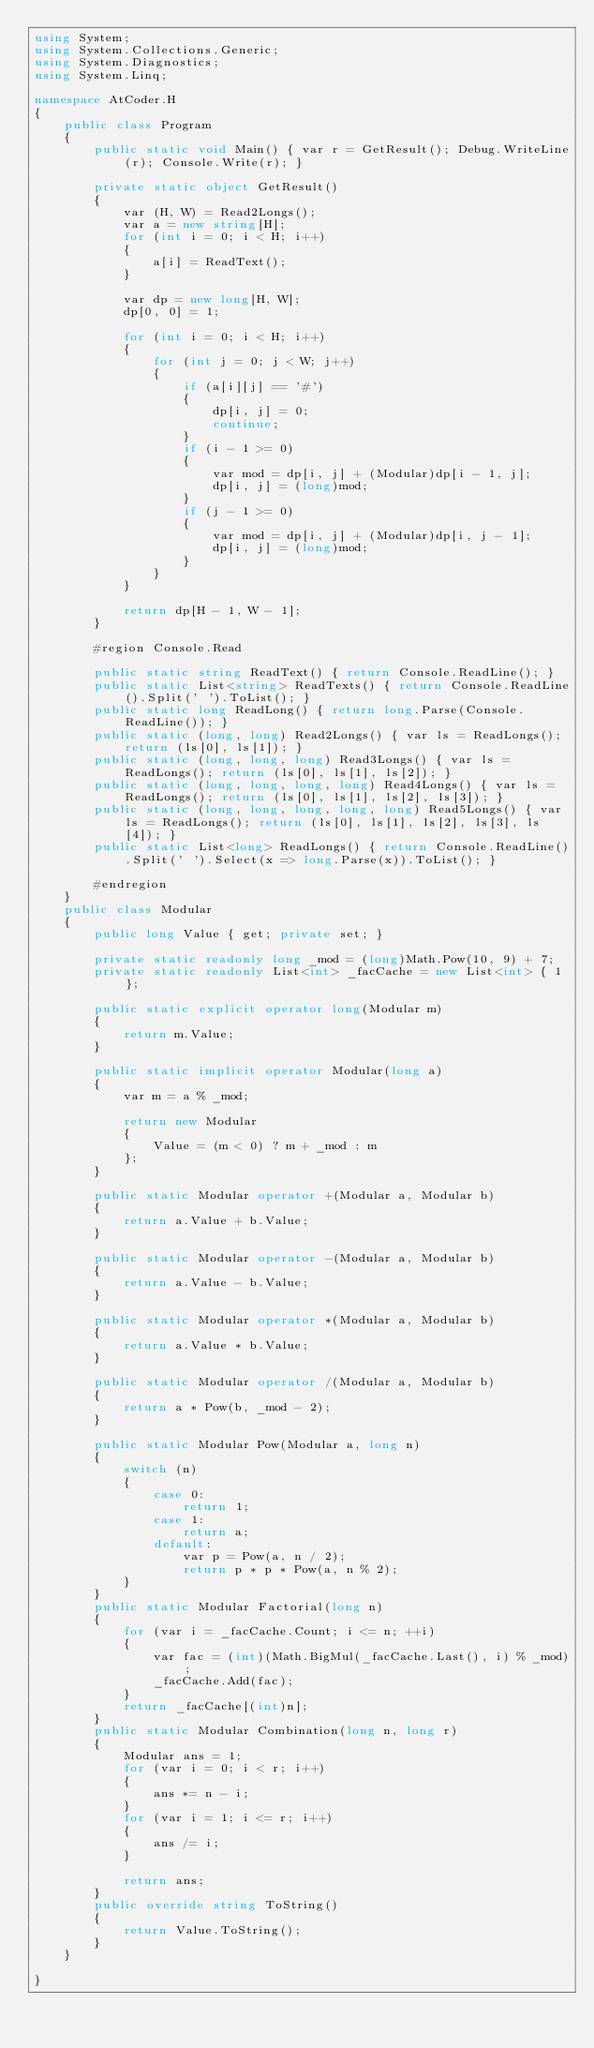<code> <loc_0><loc_0><loc_500><loc_500><_C#_>using System;
using System.Collections.Generic;
using System.Diagnostics;
using System.Linq;

namespace AtCoder.H
{
    public class Program
    {
        public static void Main() { var r = GetResult(); Debug.WriteLine(r); Console.Write(r); }

        private static object GetResult()
        {
            var (H, W) = Read2Longs();
            var a = new string[H];
            for (int i = 0; i < H; i++)
            {
                a[i] = ReadText();
            }

            var dp = new long[H, W];
            dp[0, 0] = 1;

            for (int i = 0; i < H; i++)
            {
                for (int j = 0; j < W; j++)
                {
                    if (a[i][j] == '#')
                    {
                        dp[i, j] = 0;
                        continue;
                    }
                    if (i - 1 >= 0)
                    {
                        var mod = dp[i, j] + (Modular)dp[i - 1, j];
                        dp[i, j] = (long)mod;
                    }
                    if (j - 1 >= 0)
                    {
                        var mod = dp[i, j] + (Modular)dp[i, j - 1];
                        dp[i, j] = (long)mod;
                    }
                }
            }

            return dp[H - 1, W - 1];
        }

        #region Console.Read

        public static string ReadText() { return Console.ReadLine(); }
        public static List<string> ReadTexts() { return Console.ReadLine().Split(' ').ToList(); }
        public static long ReadLong() { return long.Parse(Console.ReadLine()); }
        public static (long, long) Read2Longs() { var ls = ReadLongs(); return (ls[0], ls[1]); }
        public static (long, long, long) Read3Longs() { var ls = ReadLongs(); return (ls[0], ls[1], ls[2]); }
        public static (long, long, long, long) Read4Longs() { var ls = ReadLongs(); return (ls[0], ls[1], ls[2], ls[3]); }
        public static (long, long, long, long, long) Read5Longs() { var ls = ReadLongs(); return (ls[0], ls[1], ls[2], ls[3], ls[4]); }
        public static List<long> ReadLongs() { return Console.ReadLine().Split(' ').Select(x => long.Parse(x)).ToList(); }

        #endregion
    }
    public class Modular
    {
        public long Value { get; private set; }

        private static readonly long _mod = (long)Math.Pow(10, 9) + 7;
        private static readonly List<int> _facCache = new List<int> { 1 };

        public static explicit operator long(Modular m)
        {
            return m.Value;
        }

        public static implicit operator Modular(long a)
        {
            var m = a % _mod;

            return new Modular
            {
                Value = (m < 0) ? m + _mod : m
            };
        }

        public static Modular operator +(Modular a, Modular b)
        {
            return a.Value + b.Value;
        }

        public static Modular operator -(Modular a, Modular b)
        {
            return a.Value - b.Value;
        }

        public static Modular operator *(Modular a, Modular b)
        {
            return a.Value * b.Value;
        }

        public static Modular operator /(Modular a, Modular b)
        {
            return a * Pow(b, _mod - 2);
        }

        public static Modular Pow(Modular a, long n)
        {
            switch (n)
            {
                case 0:
                    return 1;
                case 1:
                    return a;
                default:
                    var p = Pow(a, n / 2);
                    return p * p * Pow(a, n % 2);
            }
        }
        public static Modular Factorial(long n)
        {
            for (var i = _facCache.Count; i <= n; ++i)
            {
                var fac = (int)(Math.BigMul(_facCache.Last(), i) % _mod);
                _facCache.Add(fac);
            }
            return _facCache[(int)n];
        }
        public static Modular Combination(long n, long r)
        {
            Modular ans = 1;
            for (var i = 0; i < r; i++)
            {
                ans *= n - i;
            }
            for (var i = 1; i <= r; i++)
            {
                ans /= i;
            }

            return ans;
        }
        public override string ToString()
        {
            return Value.ToString();
        }
    }

}
</code> 